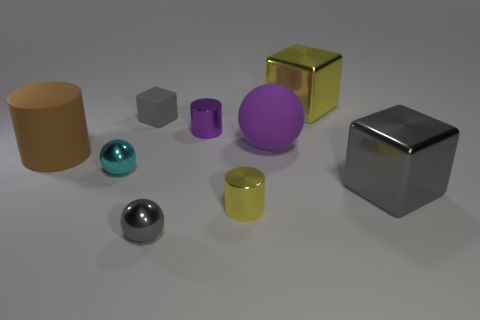Subtract all cylinders. How many objects are left? 6 Add 7 large yellow blocks. How many large yellow blocks exist? 8 Subtract 1 yellow cylinders. How many objects are left? 8 Subtract all large yellow blocks. Subtract all cyan things. How many objects are left? 7 Add 1 cyan spheres. How many cyan spheres are left? 2 